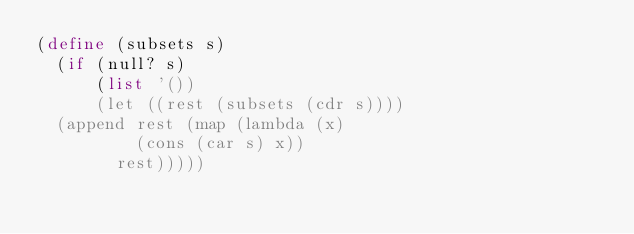Convert code to text. <code><loc_0><loc_0><loc_500><loc_500><_Scheme_>(define (subsets s)
  (if (null? s)
      (list '())
      (let ((rest (subsets (cdr s))))
	(append rest (map (lambda (x)
			    (cons (car s) x))
			  rest)))))
</code> 